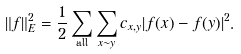Convert formula to latex. <formula><loc_0><loc_0><loc_500><loc_500>\| f \| _ { E } ^ { 2 } = \frac { 1 } { 2 } \sum _ { \text {all} } \sum _ { x \sim y } c _ { x , y } | f ( x ) - f ( y ) | ^ { 2 } .</formula> 